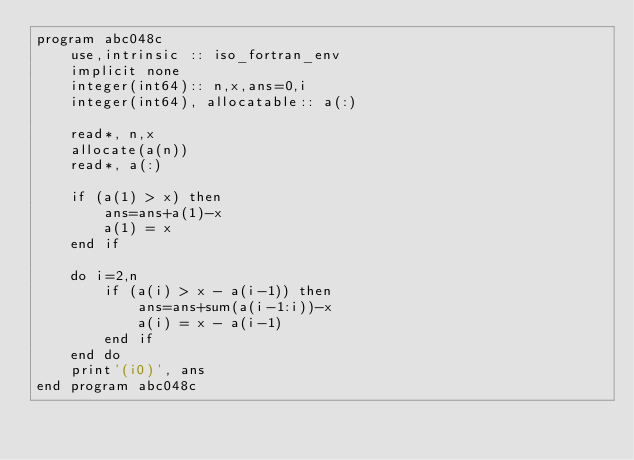<code> <loc_0><loc_0><loc_500><loc_500><_FORTRAN_>program abc048c
    use,intrinsic :: iso_fortran_env
    implicit none
    integer(int64):: n,x,ans=0,i
    integer(int64), allocatable:: a(:)

    read*, n,x
    allocate(a(n))
    read*, a(:)

    if (a(1) > x) then
        ans=ans+a(1)-x
        a(1) = x
    end if

    do i=2,n
        if (a(i) > x - a(i-1)) then
            ans=ans+sum(a(i-1:i))-x
            a(i) = x - a(i-1)
        end if
    end do
    print'(i0)', ans
end program abc048c</code> 